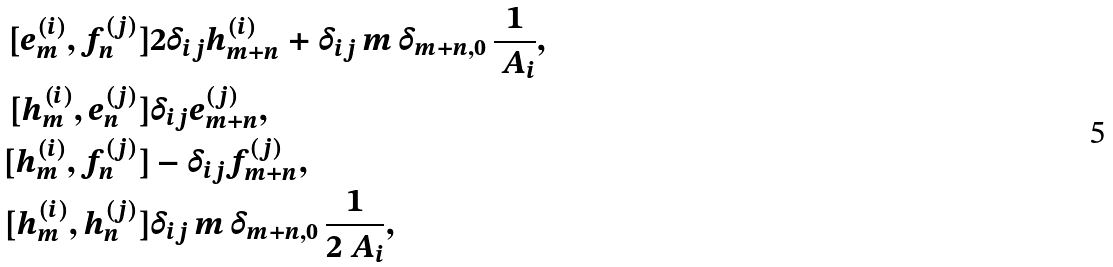<formula> <loc_0><loc_0><loc_500><loc_500>[ e ^ { ( i ) } _ { m } , f ^ { ( j ) } _ { n } ] & 2 \delta _ { i j } h ^ { ( i ) } _ { m + n } + \delta _ { i j } \, m \, \delta _ { m + n , 0 } \, \frac { 1 } { \ A _ { i } } , \\ [ h ^ { ( i ) } _ { m } , e ^ { ( j ) } _ { n } ] & \delta _ { i j } e ^ { ( j ) } _ { m + n } , \\ [ h ^ { ( i ) } _ { m } , f ^ { ( j ) } _ { n } ] & - \delta _ { i j } f ^ { ( j ) } _ { m + n } , \\ [ h ^ { ( i ) } _ { m } , h ^ { ( j ) } _ { n } ] & \delta _ { i j } \, m \, \delta _ { m + n , 0 } \, \frac { 1 } { 2 \ A _ { i } } ,</formula> 